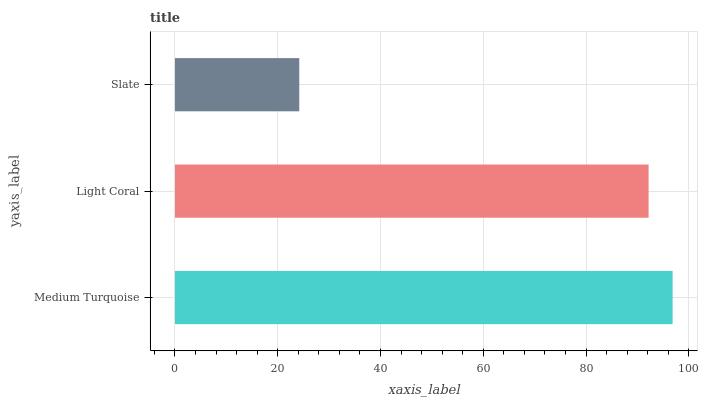Is Slate the minimum?
Answer yes or no. Yes. Is Medium Turquoise the maximum?
Answer yes or no. Yes. Is Light Coral the minimum?
Answer yes or no. No. Is Light Coral the maximum?
Answer yes or no. No. Is Medium Turquoise greater than Light Coral?
Answer yes or no. Yes. Is Light Coral less than Medium Turquoise?
Answer yes or no. Yes. Is Light Coral greater than Medium Turquoise?
Answer yes or no. No. Is Medium Turquoise less than Light Coral?
Answer yes or no. No. Is Light Coral the high median?
Answer yes or no. Yes. Is Light Coral the low median?
Answer yes or no. Yes. Is Slate the high median?
Answer yes or no. No. Is Slate the low median?
Answer yes or no. No. 